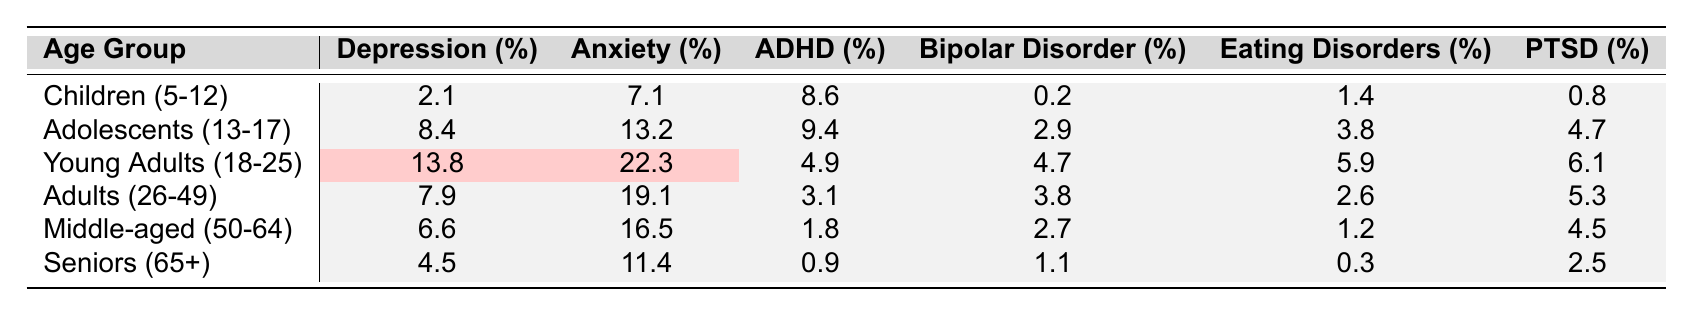What percentage of Young Adults (18-25) experience depression? The table shows that the percentage of Young Adults (18-25) experiencing depression is listed under the "Depression (%)" column. For this age group, the percentage is 13.8.
Answer: 13.8% Which age group has the highest percentage of anxiety? To determine this, I have to compare the percentages of anxiety across all age groups in the "Anxiety (%)" column. The highest percentage is 22.3%, which corresponds to the Young Adults (18-25) age group.
Answer: Young Adults (18-25) Is the prevalence of bipolar disorder higher in Adolescents (13-17) than in Seniors (65+)? I will look for the percentages of bipolar disorder in both age groups. Adolescents (13-17) have 2.9%, while Seniors (65+) have 1.1%. Since 2.9% is greater than 1.1%, the statement is true.
Answer: Yes How does the percentage of eating disorders in Adolescents (13-17) compare to that in Middle-aged individuals (50-64)? First, I find the percentage for eating disorders in both age groups: Adolescents (13-17) have 3.8%, and Middle-aged (50-64) have 1.2%. Since 3.8% is greater than 1.2%, Adolescents have a higher percentage of eating disorders than Middle-aged individuals.
Answer: Higher in Adolescents (13-17) What is the average percentage of PTSD across all age groups? I will add the percentages of PTSD: (0.8 + 4.7 + 6.1 + 5.3 + 4.5 + 2.5) = 24.9. There are 6 age groups, so I divide 24.9 by 6 to find the average. This gives me an average of approximately 4.15%.
Answer: 4.15% Which mental health disorder has the highest prevalence among Children (5-12)? To answer this, I will look at the data for Children (5-12) and check the percentages for all disorders. The highest percentage is 8.6% for ADHD.
Answer: ADHD (8.6%) Are the percentages of depression among Middle-aged (50-64) and Seniors (65+) combined greater than that of Young Adults (18-25)? I will first add the percentages of depression for Middle-aged (50-64) and Seniors (65+): (6.6 + 4.5) = 11.1%. This is less than the 13.8% for Young Adults (18-25). So, the combined percentage is not greater.
Answer: No What is the difference in PTSD prevalence between Young Adults (18-25) and Children (5-12)? The PTSD prevalence is 6.1% for Young Adults (18-25) and 0.8% for Children (5-12). To calculate the difference, I subtract: 6.1% - 0.8% = 5.3%.
Answer: 5.3% How does the prevalence of depression change from Adolescents (13-17) to Adults (26-49)? For Adolescents (13-17), the depression percentage is 8.4%, and for Adults (26-49), it is 7.9%. The change is 8.4% - 7.9% = 0.5%, indicating a decrease in prevalence.
Answer: Decrease of 0.5% What percentage of Young Adults (18-25) report having ADHD compared to Seniors (65+)? The ADHD prevalence in Young Adults (18-25) is 4.9%, while it is 0.9% in Seniors (65+). Comparing these, Young Adults have a higher percentage of ADHD.
Answer: Higher in Young Adults (18-25) 